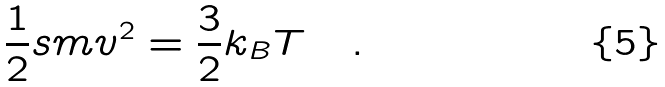Convert formula to latex. <formula><loc_0><loc_0><loc_500><loc_500>\frac { 1 } { 2 } s m v ^ { 2 } = \frac { 3 } { 2 } k _ { B } T \quad .</formula> 